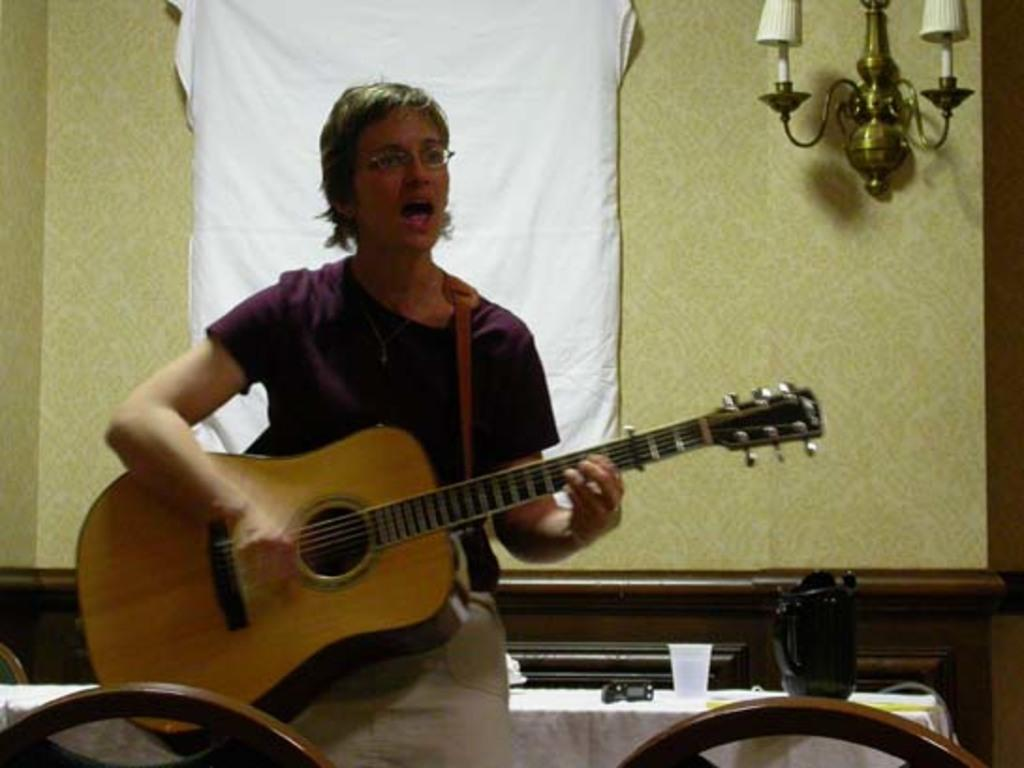What is the woman in the image doing? The woman is playing a guitar in the image. What objects can be seen in the background of the image? There is a table, a glass, a jug, a lamp, and a chair in the background of the image. Can you describe the setting where the woman is playing the guitar? The woman is playing the guitar in a room with a table, a glass, a jug, a lamp, and a chair in the background. How many trucks are parked outside the room in the image? There is no information about trucks in the image, as it only shows a woman playing a guitar and objects in the background of a room. 